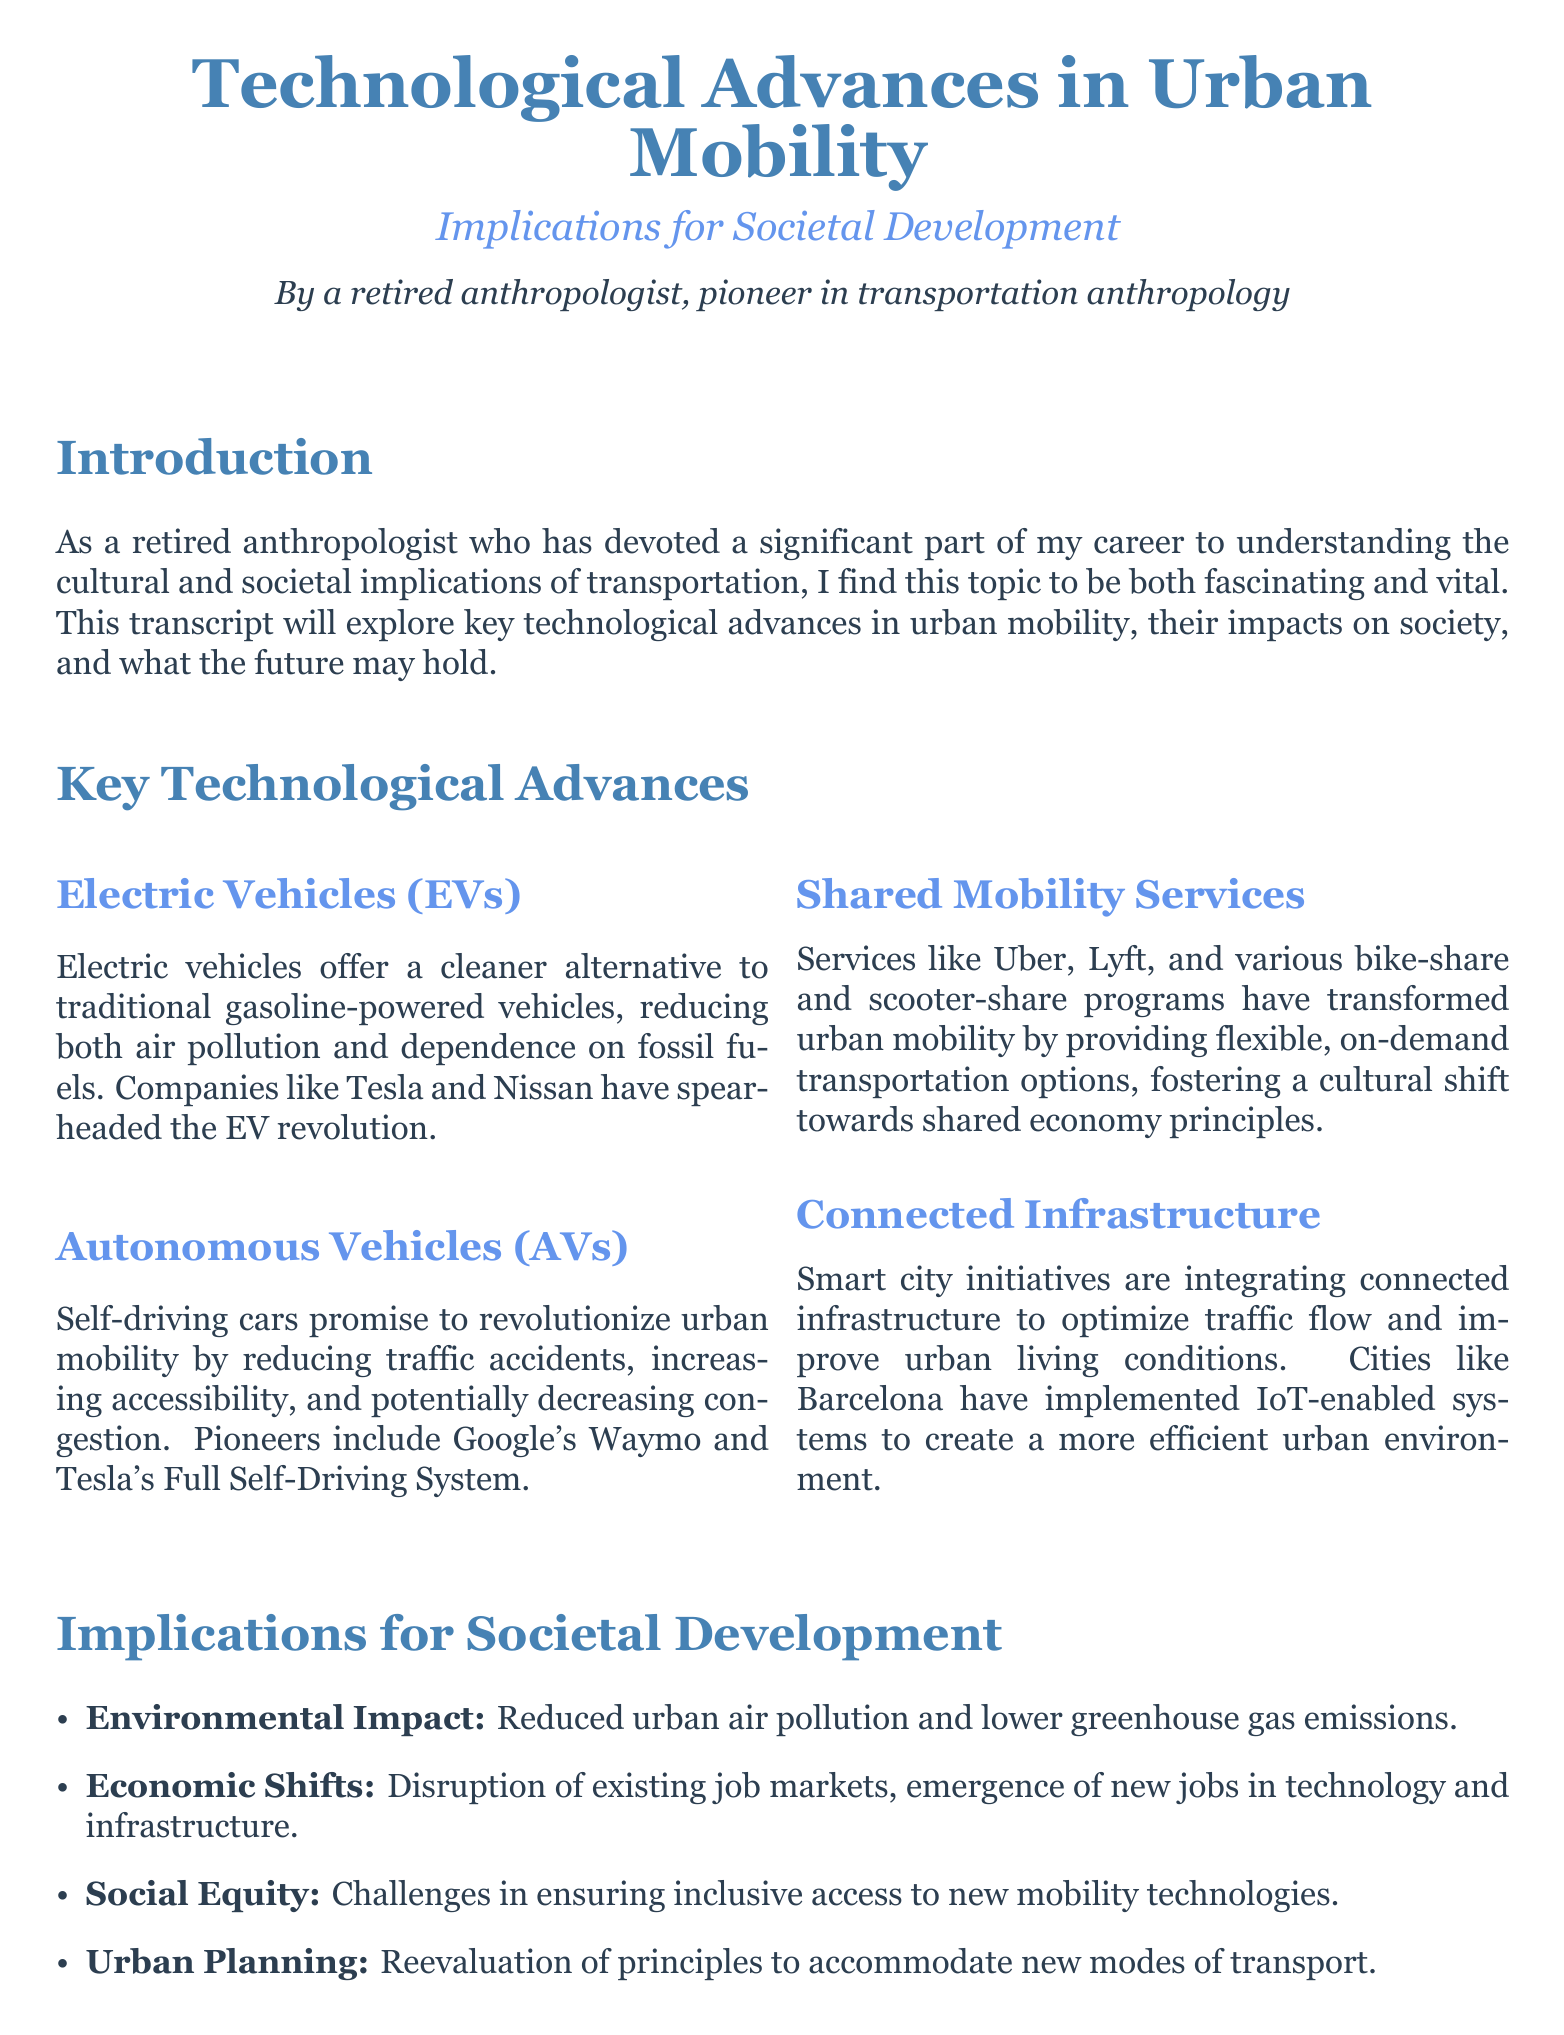what is the title of the document? The title is prominently displayed at the top of the document, clearly identifying its focus.
Answer: Technological Advances in Urban Mobility who is the author of the transcript? The author’s name is mentioned beneath the title, establishing their credibility in the field.
Answer: A retired anthropologist, pioneer in transportation anthropology what technology aims to reduce air pollution? This technology is specifically highlighted among the key advances discussed in the document, addressing environmental concerns.
Answer: Electric Vehicles (EVs) which company is associated with autonomous vehicles? This company is mentioned as a leader in the development of self-driving technology, illustrating its innovation focus.
Answer: Google's Waymo what economic effect is mentioned regarding new mobility technologies? This refers to the impact on job markets, which is a core concern in societal development discussed in the document.
Answer: Disruption of existing job markets name a city implementing smart city initiatives. This city is provided as an example of successful integration of connected infrastructure to improve urban living.
Answer: Barcelona what is a challenge related to social equity mentioned? This challenge is noted in the implications section, highlighting the potential barriers to access for certain populations.
Answer: Inclusive access how do technological advances affect urban planning? The document mentions this effect as a necessary reevaluation of principles in response to new transportation modes.
Answer: Reevaluation of principles what type of transportation services does Uber provide? This information addresses the specific category of mobility service that is transformed by current advances.
Answer: Shared Mobility Services 